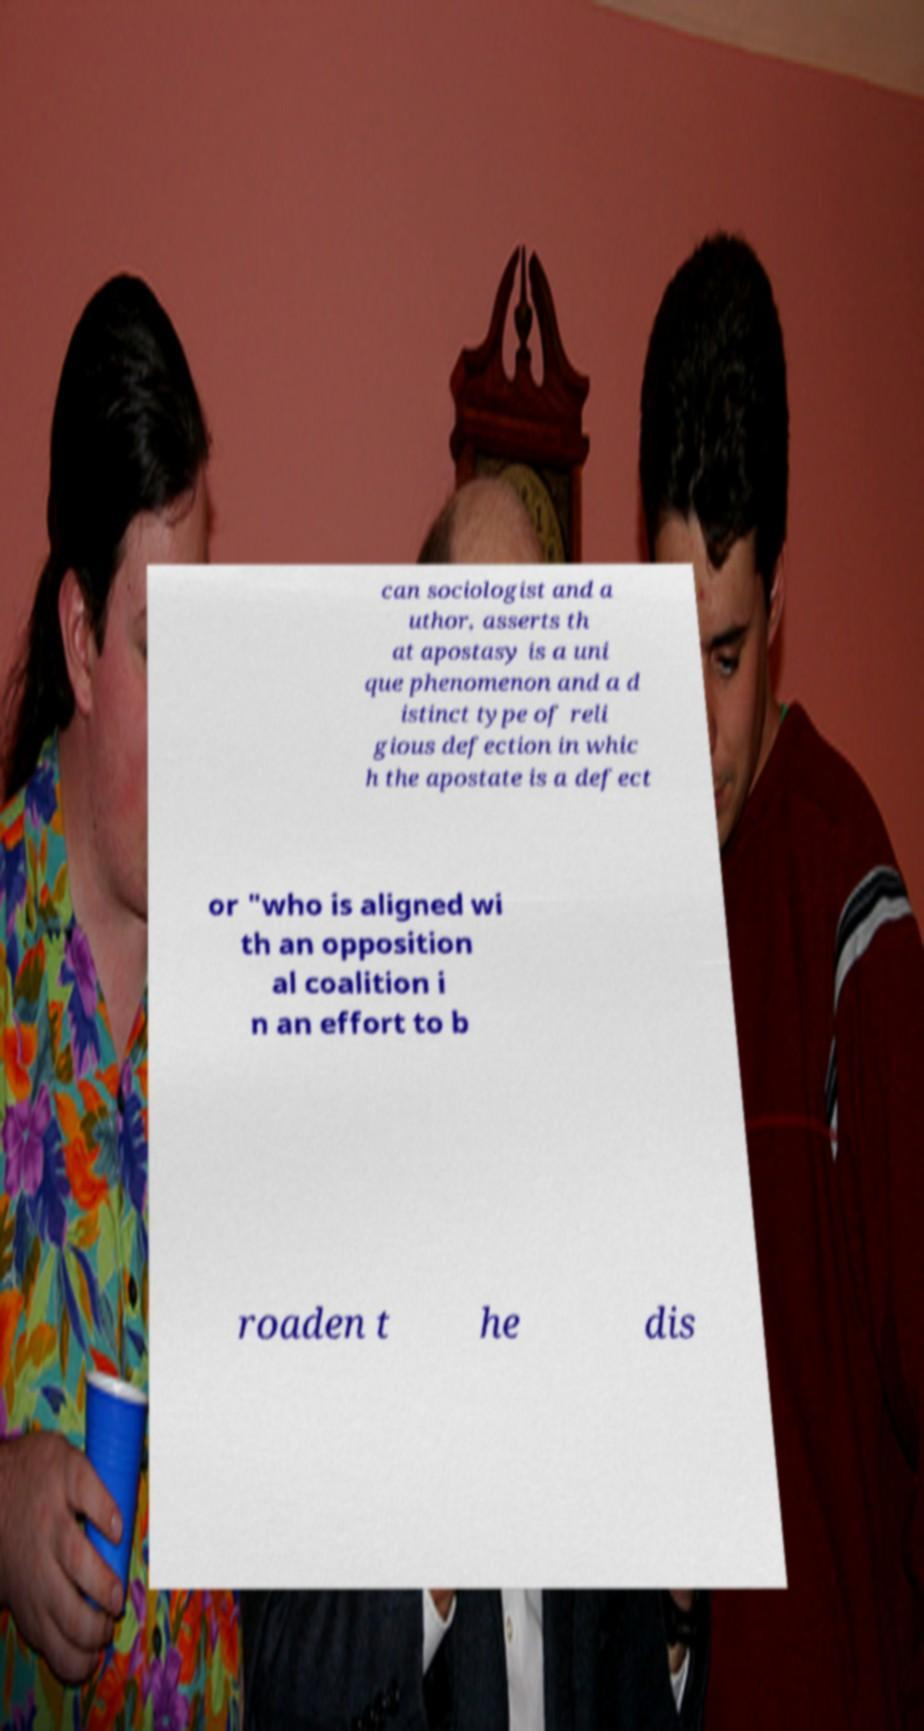Could you extract and type out the text from this image? can sociologist and a uthor, asserts th at apostasy is a uni que phenomenon and a d istinct type of reli gious defection in whic h the apostate is a defect or "who is aligned wi th an opposition al coalition i n an effort to b roaden t he dis 